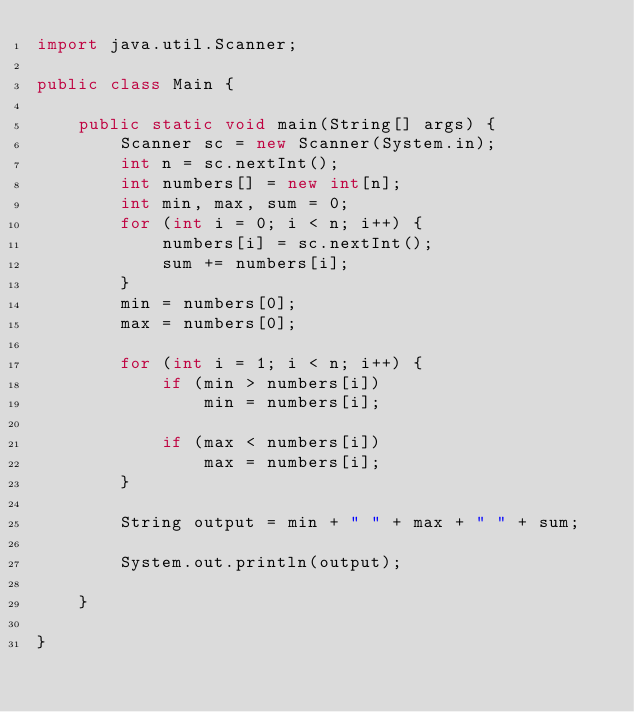<code> <loc_0><loc_0><loc_500><loc_500><_Java_>import java.util.Scanner;

public class Main {

	public static void main(String[] args) {
		Scanner sc = new Scanner(System.in);
		int n = sc.nextInt();
		int numbers[] = new int[n];
		int min, max, sum = 0;
		for (int i = 0; i < n; i++) {
			numbers[i] = sc.nextInt();
			sum += numbers[i];
		}
		min = numbers[0];
		max = numbers[0];

		for (int i = 1; i < n; i++) {
			if (min > numbers[i])
				min = numbers[i];

			if (max < numbers[i])
				max = numbers[i];
		}

		String output = min + " " + max + " " + sum;

		System.out.println(output);

	}

}</code> 